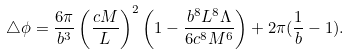<formula> <loc_0><loc_0><loc_500><loc_500>\bigtriangleup \phi = { \frac { 6 \pi } { b ^ { 3 } } } \left ( \frac { c M } { L } \right ) ^ { 2 } \left ( 1 - \frac { b ^ { 8 } L ^ { 8 } \Lambda } { 6 c ^ { 8 } M ^ { 6 } } \right ) + 2 \pi ( \frac { 1 } { b } - 1 ) .</formula> 